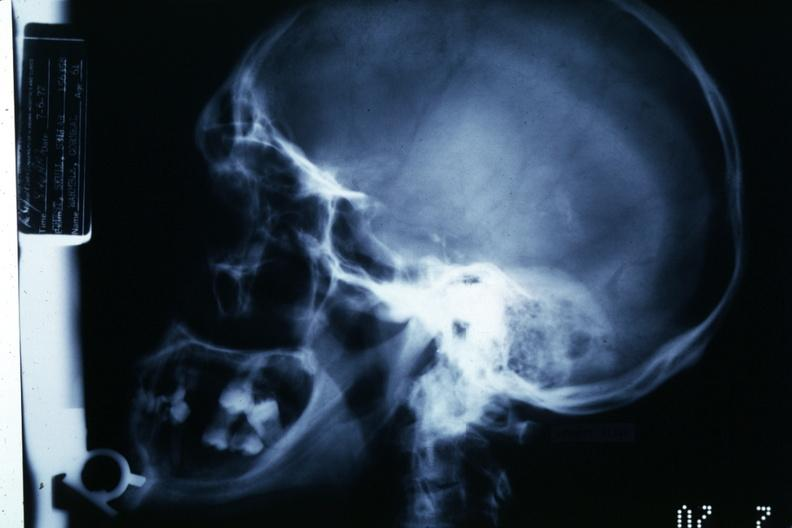what does this image show?
Answer the question using a single word or phrase. X-ray showing large sella turcica 